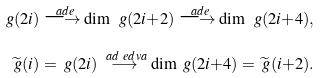<formula> <loc_0><loc_0><loc_500><loc_500>\ g ( 2 i ) \overset { \ a d e } { \longrightarrow } \dim \ g ( 2 i { + } 2 ) \overset { \ a d e } { \longrightarrow } \dim \ g ( 2 i { + } 4 ) , \\ \widetilde { \ g } ( i ) = \ g ( 2 i ) \overset { \ a d \ e d v a } { \longrightarrow } \dim \ g ( 2 i { + } 4 ) = \widetilde { \ g } ( i { + } 2 ) .</formula> 